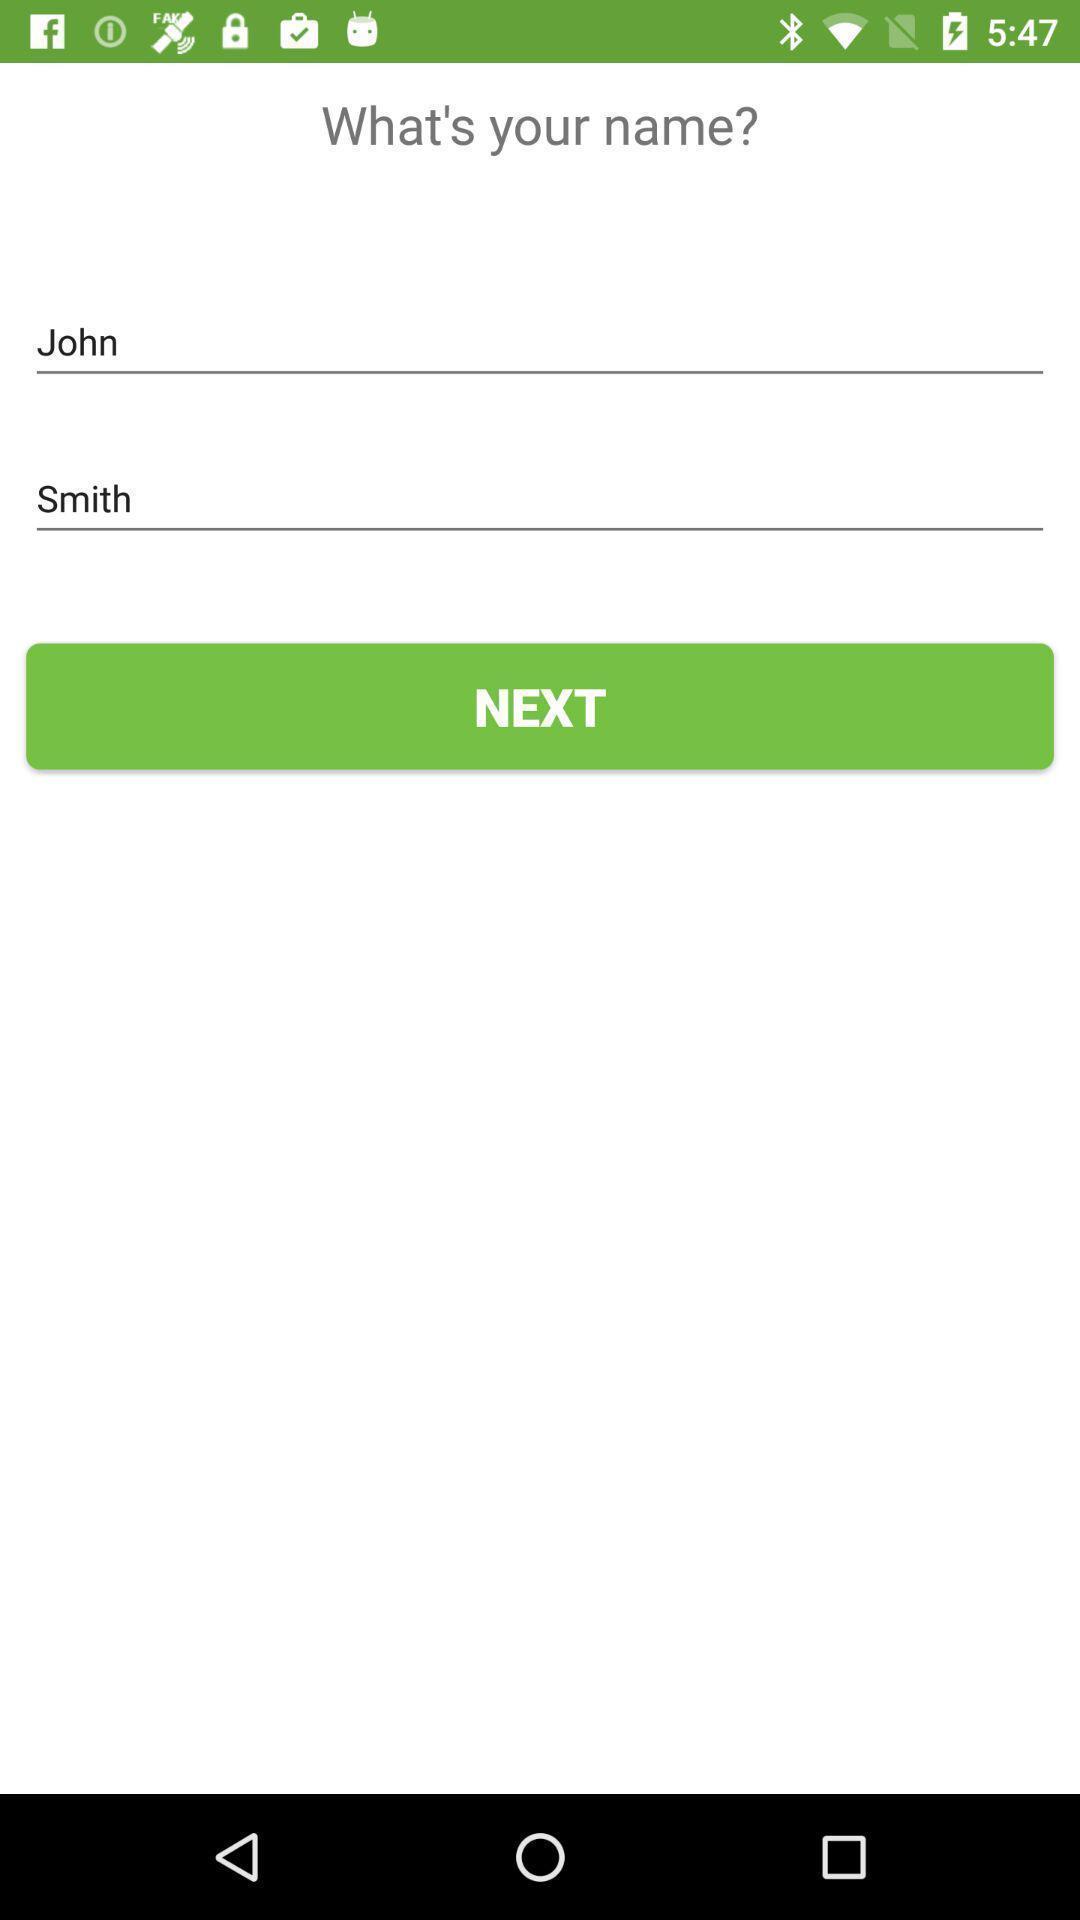Summarize the main components in this picture. Page displaying what 's your name with next option. 